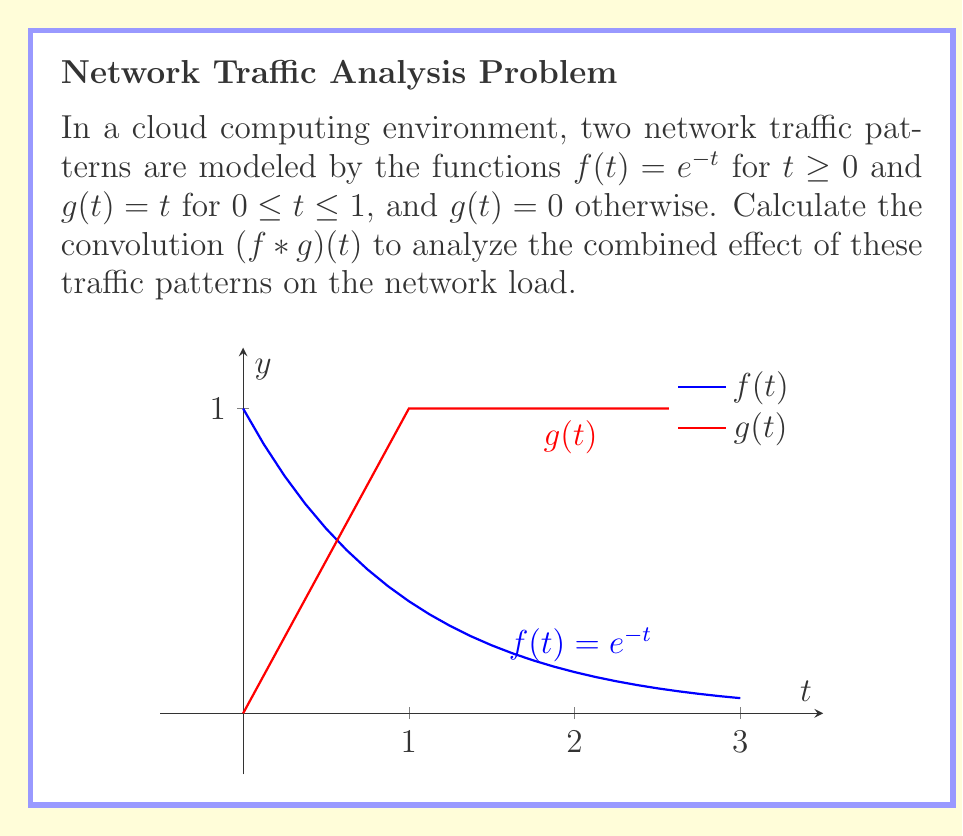Provide a solution to this math problem. To calculate the convolution of $f(t)$ and $g(t)$, we use the formula:

$$(f * g)(t) = \int_{0}^{t} f(t-\tau)g(\tau)d\tau$$

Step 1: Define the integrand
$$f(t-\tau)g(\tau) = e^{-(t-\tau)} \cdot \begin{cases} 
\tau & \text{if } 0 \leq \tau \leq 1 \\
0 & \text{otherwise}
\end{cases}$$

Step 2: Set up the integral
$$(f * g)(t) = \int_{0}^{\min(t,1)} e^{-(t-\tau)} \tau d\tau$$

Step 3: Solve the integral
$$\begin{align}
(f * g)(t) &= \int_{0}^{\min(t,1)} e^{-(t-\tau)} \tau d\tau \\
&= e^{-t} \int_{0}^{\min(t,1)} e^{\tau} \tau d\tau \\
&= e^{-t} \left[ e^{\tau}(\tau-1) \right]_{0}^{\min(t,1)} \\
&= e^{-t} \left[ e^{\min(t,1)}(\min(t,1)-1) - (-1) \right]
\end{align}$$

Step 4: Simplify for different ranges of t
For $0 \leq t \leq 1$:
$$(f * g)(t) = e^{-t} \left[ e^t(t-1) + 1 \right] = t - 1 + e^{-t}$$

For $t > 1$:
$$(f * g)(t) = e^{-t} \left[ e(0) + 1 \right] = e^{-t} + e^{1-t}$$

Step 5: Combine the results
$$(f * g)(t) = \begin{cases}
t - 1 + e^{-t} & \text{if } 0 \leq t \leq 1 \\
e^{-t} + e^{1-t} & \text{if } t > 1
\end{cases}$$
Answer: $$(f * g)(t) = \begin{cases}
t - 1 + e^{-t} & \text{if } 0 \leq t \leq 1 \\
e^{-t} + e^{1-t} & \text{if } t > 1
\end{cases}$$ 